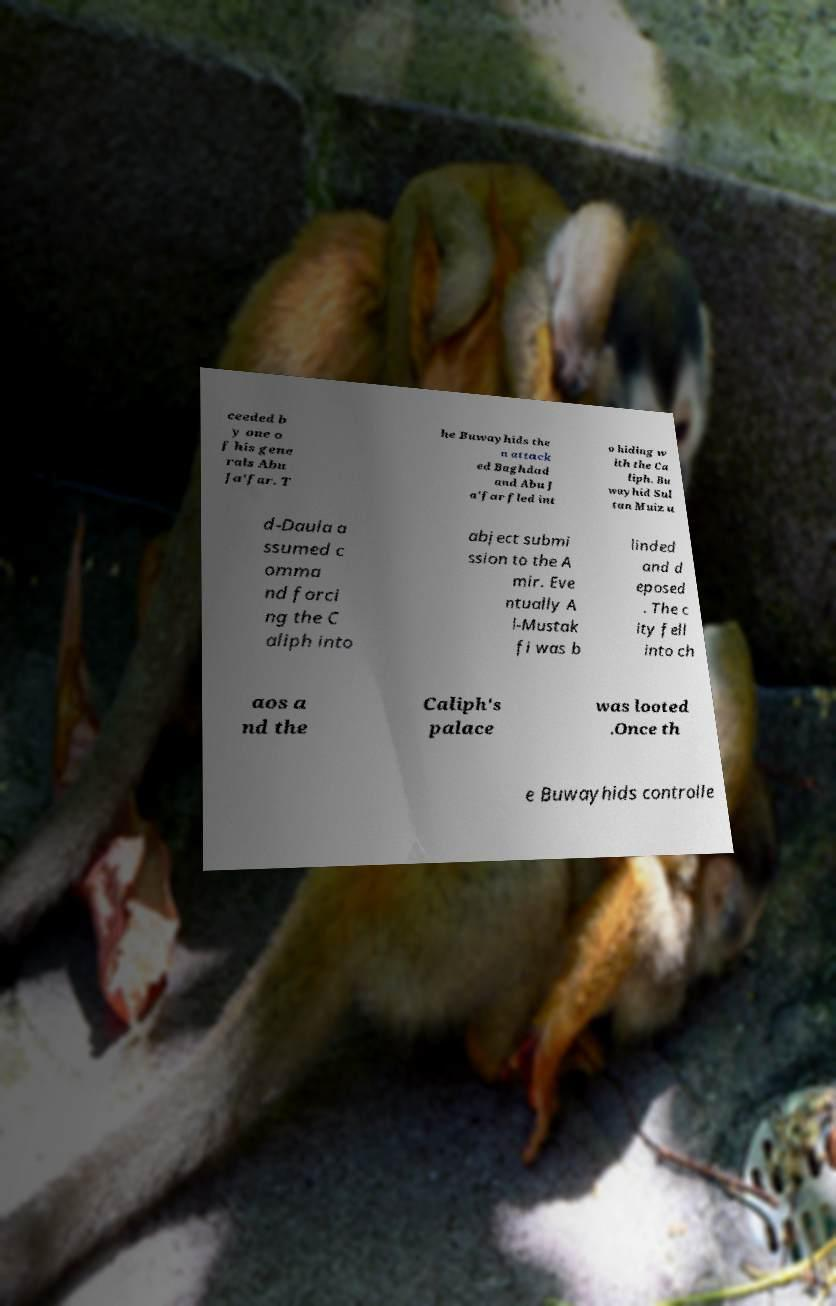Please identify and transcribe the text found in this image. ceeded b y one o f his gene rals Abu Ja'far. T he Buwayhids the n attack ed Baghdad and Abu J a'far fled int o hiding w ith the Ca liph. Bu wayhid Sul tan Muiz u d-Daula a ssumed c omma nd forci ng the C aliph into abject submi ssion to the A mir. Eve ntually A l-Mustak fi was b linded and d eposed . The c ity fell into ch aos a nd the Caliph's palace was looted .Once th e Buwayhids controlle 